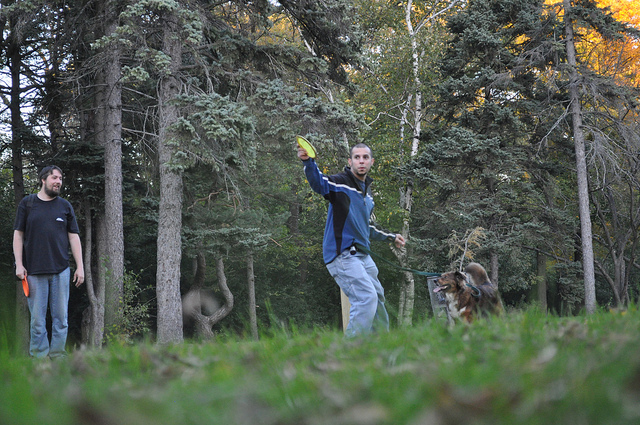<image>What kind of orchid are the boys in? It is ambiguous what kind of orchid the boys are in. It could be an apple, forest, park, tree, woods, or oak. What kind of orchid are the boys in? I don't know what kind of orchid the boys are in. It could be apple, forest, park, tree, woods, or oak. 